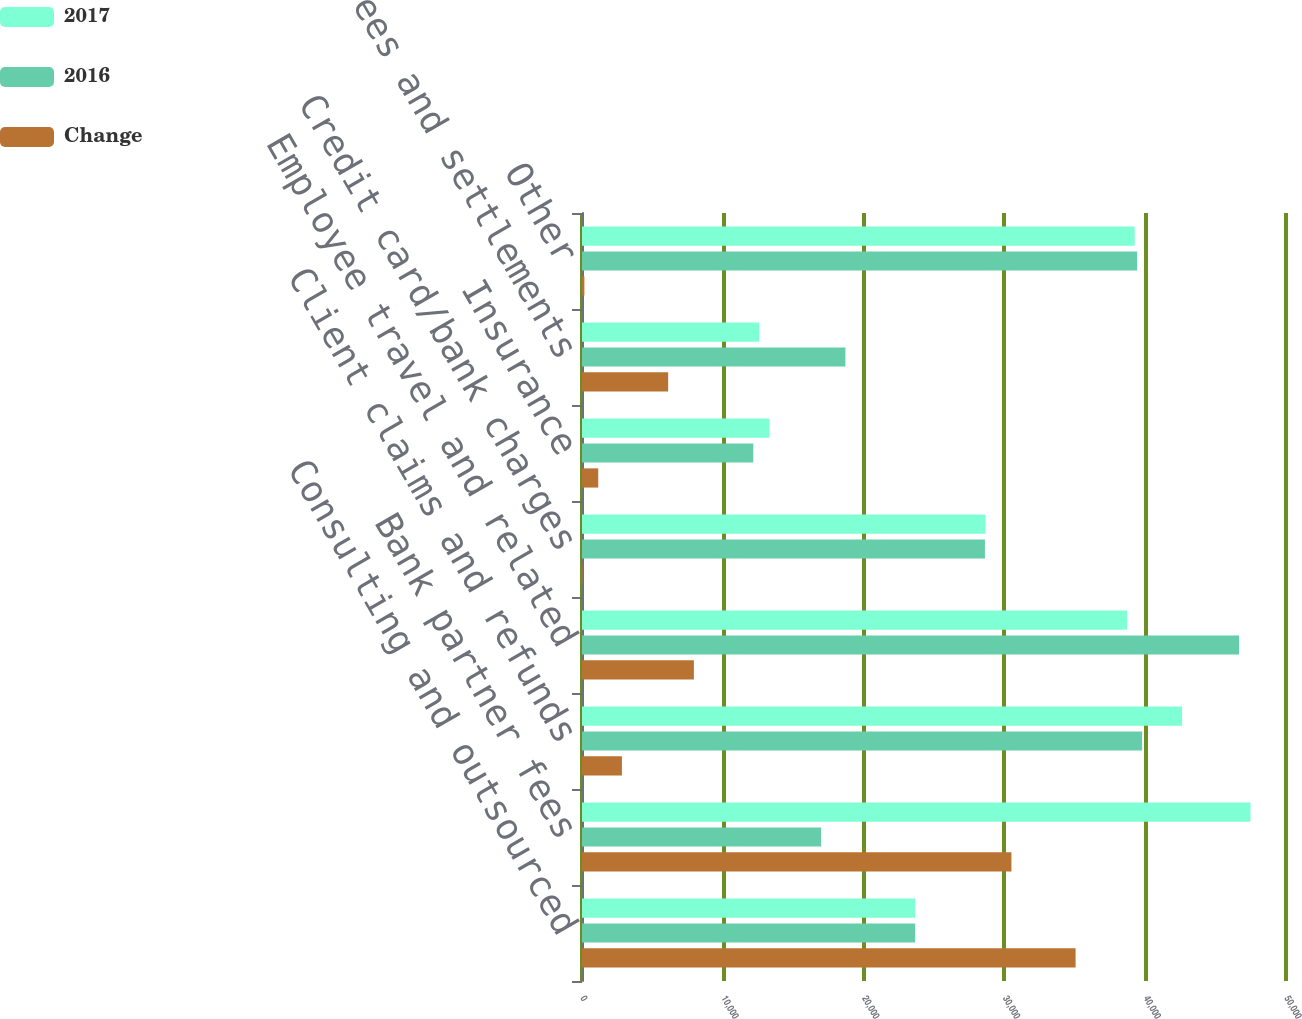Convert chart. <chart><loc_0><loc_0><loc_500><loc_500><stacked_bar_chart><ecel><fcel>Consulting and outsourced<fcel>Bank partner fees<fcel>Client claims and refunds<fcel>Employee travel and related<fcel>Credit card/bank charges<fcel>Insurance<fcel>Legal fees and settlements<fcel>Other<nl><fcel>2017<fcel>23662.5<fcel>47479<fcel>42618<fcel>38719<fcel>28658<fcel>13320<fcel>12589<fcel>39257<nl><fcel>2016<fcel>23662.5<fcel>16980<fcel>39782<fcel>46665<fcel>28618<fcel>12167<fcel>18707<fcel>39426<nl><fcel>Change<fcel>35057<fcel>30499<fcel>2836<fcel>7946<fcel>40<fcel>1153<fcel>6118<fcel>169<nl></chart> 